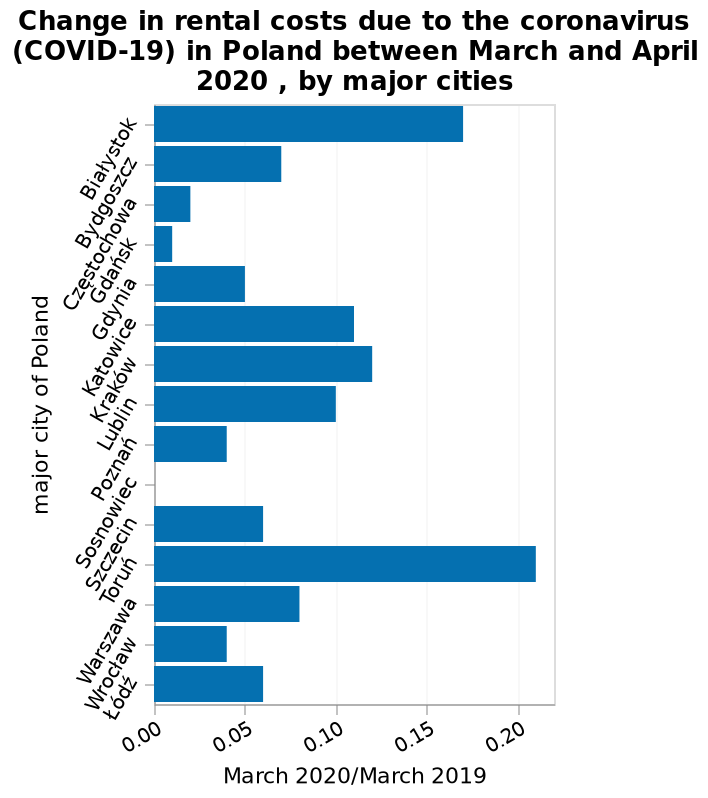<image>
How are the major cities of Poland represented on the y-axis?  The major cities of Poland are represented on the y-axis using a categorical scale, with Białystok on one end and Łódź on the other. Are the major cities of Poland represented on the y-axis using a numerical scale, with Białystok on one end and Łódź on the other? No. The major cities of Poland are represented on the y-axis using a categorical scale, with Białystok on one end and Łódź on the other. 